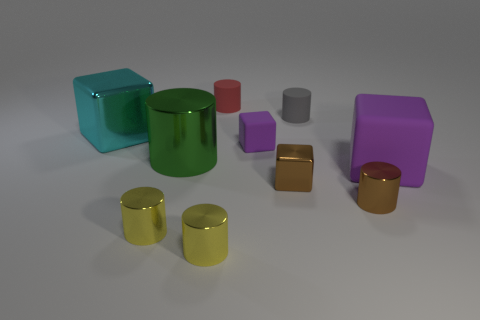Subtract all small matte cubes. How many cubes are left? 3 Subtract all gray cylinders. How many cylinders are left? 5 Subtract 1 blocks. How many blocks are left? 3 Subtract all blue cylinders. Subtract all brown cubes. How many cylinders are left? 6 Subtract all cylinders. How many objects are left? 4 Subtract all large green matte things. Subtract all large purple things. How many objects are left? 9 Add 9 large metallic cubes. How many large metallic cubes are left? 10 Add 4 metal cubes. How many metal cubes exist? 6 Subtract 1 brown cylinders. How many objects are left? 9 